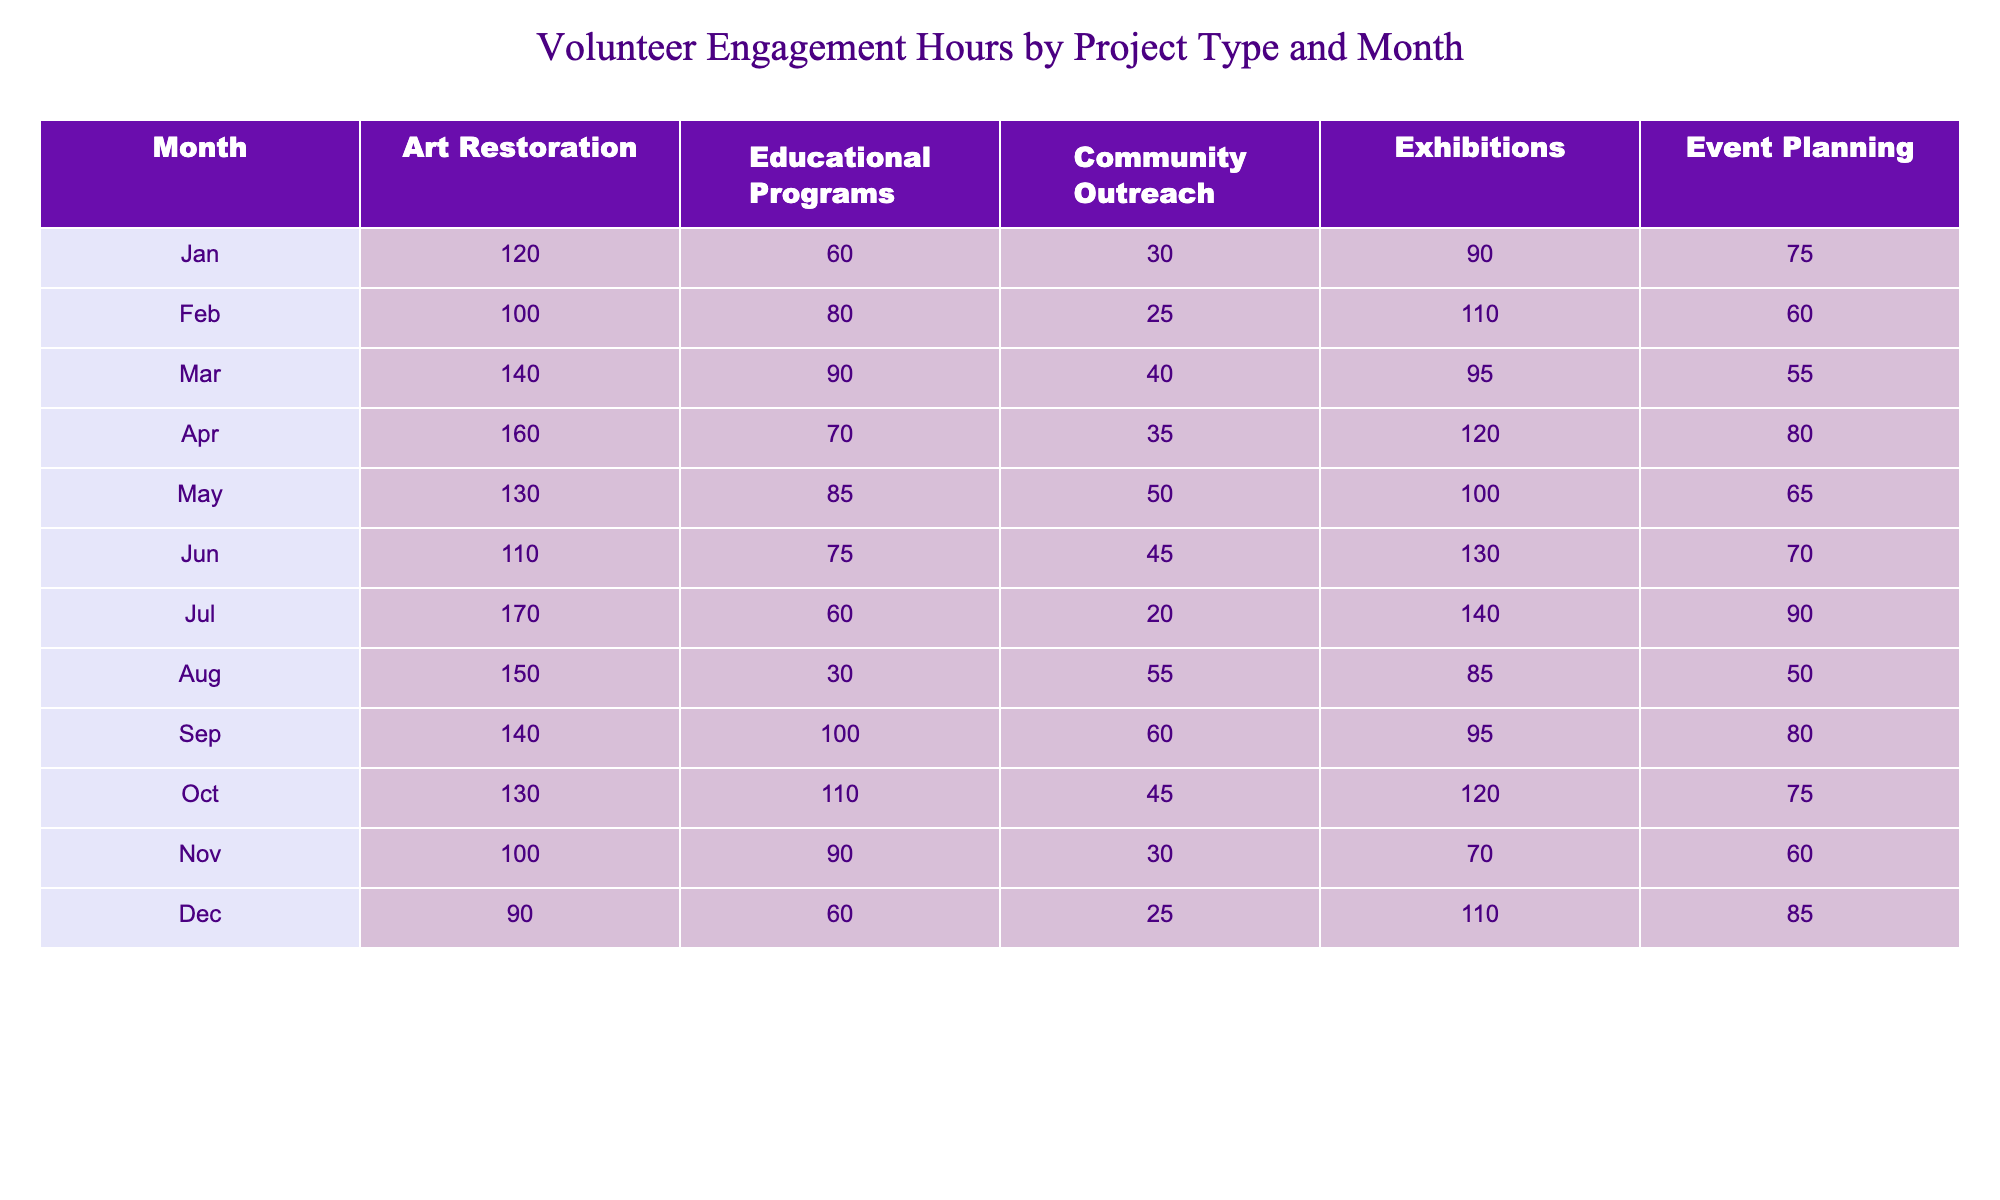What was the total number of volunteer engagement hours in January? In January, the total can be calculated by summing all project types: 120 (Art Restoration) + 60 (Educational Programs) + 30 (Community Outreach) + 90 (Exhibitions) + 75 (Event Planning) = 375 hours.
Answer: 375 hours Which project type had the highest volunteer engagement in March? In March, the numbers are: Art Restoration = 140, Educational Programs = 90, Community Outreach = 40, Exhibitions = 95, Event Planning = 55. The highest is Art Restoration with 140 hours.
Answer: Art Restoration What was the average engagement hours for Community Outreach over the year? To find the average, sum the Community Outreach hours: 30 + 25 + 40 + 35 + 50 + 45 + 20 + 55 + 60 + 45 + 30 + 25 =  455. There are 12 months, so the average is 455/12 ≈ 37.92 hours.
Answer: 37.92 hours Did more volunteer hours go to Educational Programs or Exhibitions overall? Calculate totals: Educational Programs = 60 + 80 + 90 + 70 + 85 + 75 + 60 + 30 + 100 + 110 + 90 + 60 = 800; Exhibitions = 90 + 110 + 95 + 120 + 100 + 130 + 140 + 85 + 95 + 120 + 70 + 110 = 1,360. Since 1,360 > 800, Exhibitions had more hours.
Answer: No, Educational Programs did not In which month did Event Planning have its lowest volunteer engagement hours? Check the Event Planning hours month by month: January (75), February (60), March (55), April (80), May (65), June (70), July (90), August (50), September (80), October (75), November (60), December (85). The lowest was in August with 50 hours.
Answer: August What were the total volunteer engagement hours for the year across all projects? Summing all project hours for each month gives: (375 + 365 + 375 + 405 + 360 + 430 + 380 + 315 + 475 + 435 + 330 + 330) = 4,586 hours.
Answer: 4,586 hours In which month was Community Outreach engagement the highest? Looking at Community Outreach: January (30), February (25), March (40), April (35), May (50), June (45), July (20), August (55), September (60), October (45), November (30), December (25). The maximum was in September with 60 hours.
Answer: September What is the difference in volunteer hours for Art Restoration between July and January? Art Restoration hours are: January (120) and July (170). Calculating the difference: 170 - 120 = 50 hours more in July compared to January.
Answer: 50 hours Which two project types had the most similar engagement hours in November? In November: Educational Programs (90) and Event Planning (60) provide the values. The largest difference lies between these two: 90 - 60 = 30 hours. Thus, they are the closest in engagement.
Answer: Educational Programs and Event Planning Was there an increase or decrease in Educational Programs from February to March? February had 80 hours and March had 90 hours for Educational Programs. The increase is 90 - 80 = 10 hours, indicating growth in engagement.
Answer: Increase Which project type showed a decline in engagement from October to November? October had the following values: Art Restoration (130), Educational Programs (110), Community Outreach (45), Exhibitions (120), Event Planning (75). In November, Art Restoration dropped to 100, implying a decline of 30 hours.
Answer: Art Restoration 